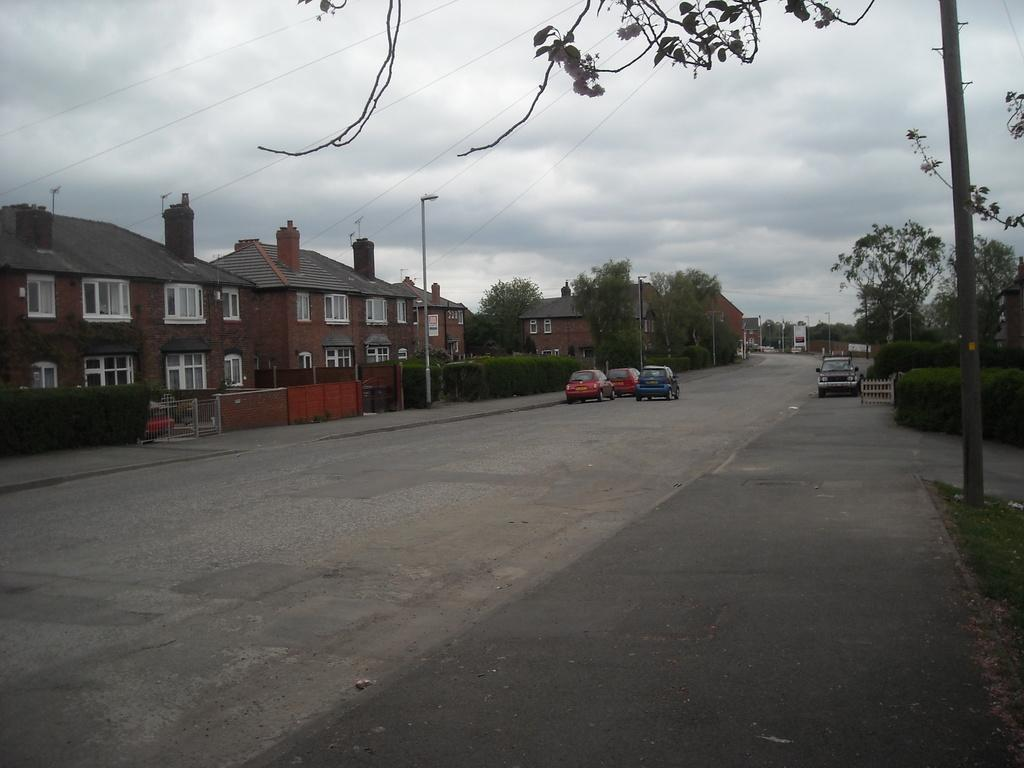What can be seen on the road in the image? There are vehicles on the road in the image. What type of structures are present in the image? There are buildings in the image. What type of vegetation is visible in the image? There are trees in the image. What is visible in the background of the image? The sky is visible in the background of the image. How much profit does the cabbage generate in the image? There is no cabbage present in the image, so it is not possible to determine its profit. 